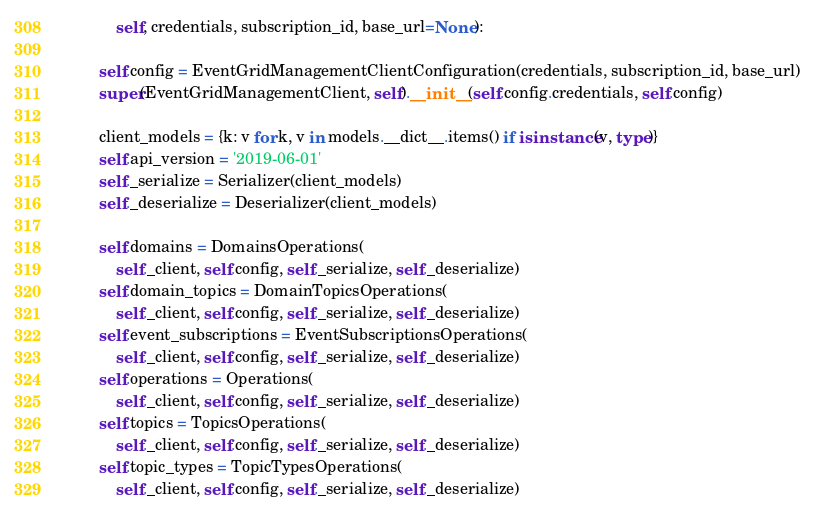<code> <loc_0><loc_0><loc_500><loc_500><_Python_>            self, credentials, subscription_id, base_url=None):

        self.config = EventGridManagementClientConfiguration(credentials, subscription_id, base_url)
        super(EventGridManagementClient, self).__init__(self.config.credentials, self.config)

        client_models = {k: v for k, v in models.__dict__.items() if isinstance(v, type)}
        self.api_version = '2019-06-01'
        self._serialize = Serializer(client_models)
        self._deserialize = Deserializer(client_models)

        self.domains = DomainsOperations(
            self._client, self.config, self._serialize, self._deserialize)
        self.domain_topics = DomainTopicsOperations(
            self._client, self.config, self._serialize, self._deserialize)
        self.event_subscriptions = EventSubscriptionsOperations(
            self._client, self.config, self._serialize, self._deserialize)
        self.operations = Operations(
            self._client, self.config, self._serialize, self._deserialize)
        self.topics = TopicsOperations(
            self._client, self.config, self._serialize, self._deserialize)
        self.topic_types = TopicTypesOperations(
            self._client, self.config, self._serialize, self._deserialize)
</code> 